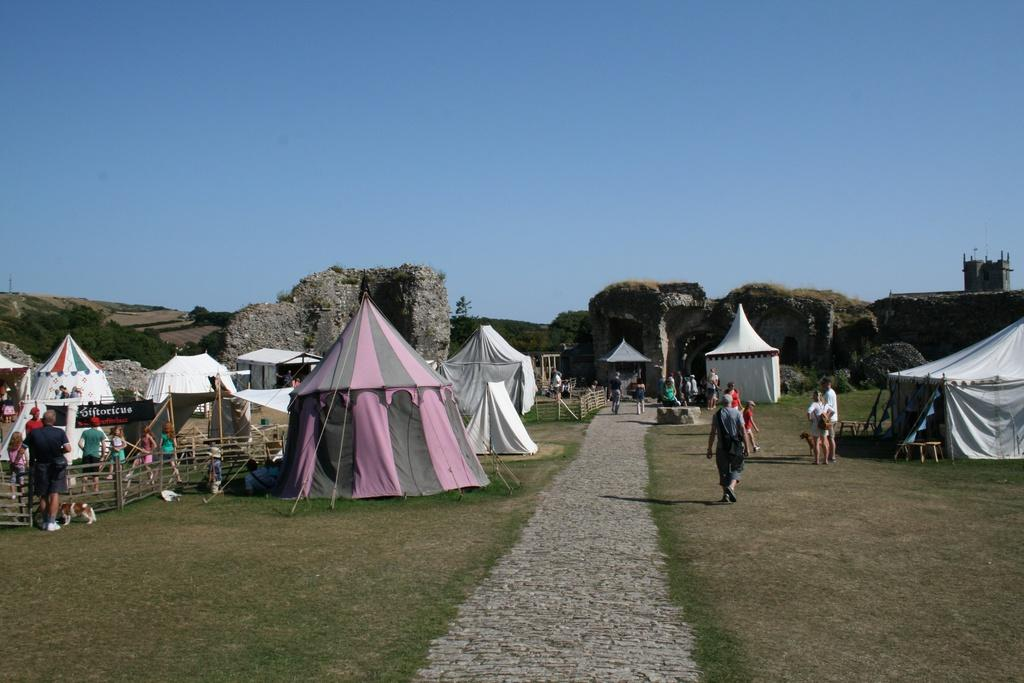How many people are in the image? There is a group of people in the image, but the exact number cannot be determined from the provided facts. What structures are visible in the image? There are tents and a wooden fence visible in the image. What is the purpose of the name board in the image? The purpose of the name board in the image is to identify a location or event. What can be seen in the background of the image? There are trees and the sky visible in the background of the image. What type of knife is being used to cut the engine in the image? There is no knife or engine present in the image. How many fish can be seen swimming in the background of the image? There are no fish visible in the image; only trees and the sky can be seen in the background. 